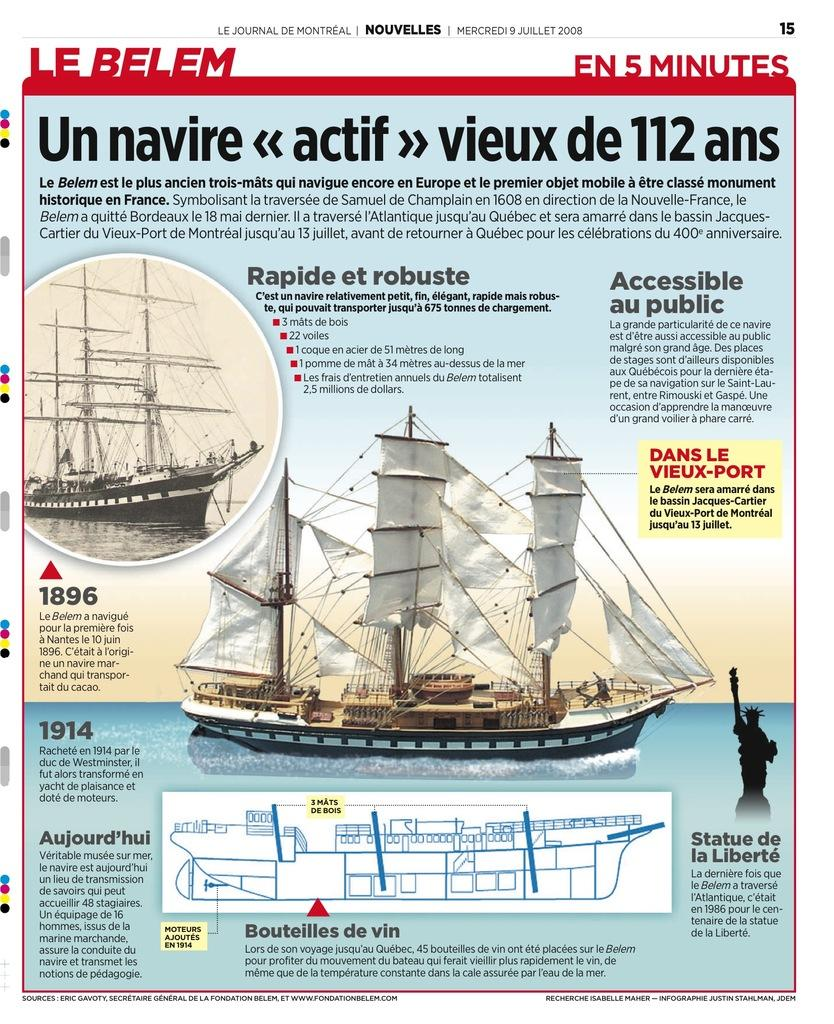What is present on the poster in the image? The poster contains text and images. Can you describe the content of the poster? The poster contains text and images, but the specific content cannot be determined from the provided facts. How many airports are depicted on the poster? There is no mention of airports in the image, as the poster contains text and images, but the specific content cannot be determined from the provided facts. Can you tell me how many keys are shown in the images on the poster? There is no mention of keys in the image, as the poster contains text and images, but the specific content cannot be determined from the provided facts. 